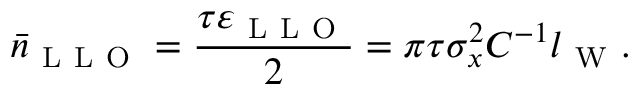<formula> <loc_0><loc_0><loc_500><loc_500>\bar { n } _ { L L O } = \frac { \tau \varepsilon _ { L L O } } { 2 } = \pi \tau \sigma _ { x } ^ { 2 } C ^ { - 1 } l _ { W } .</formula> 